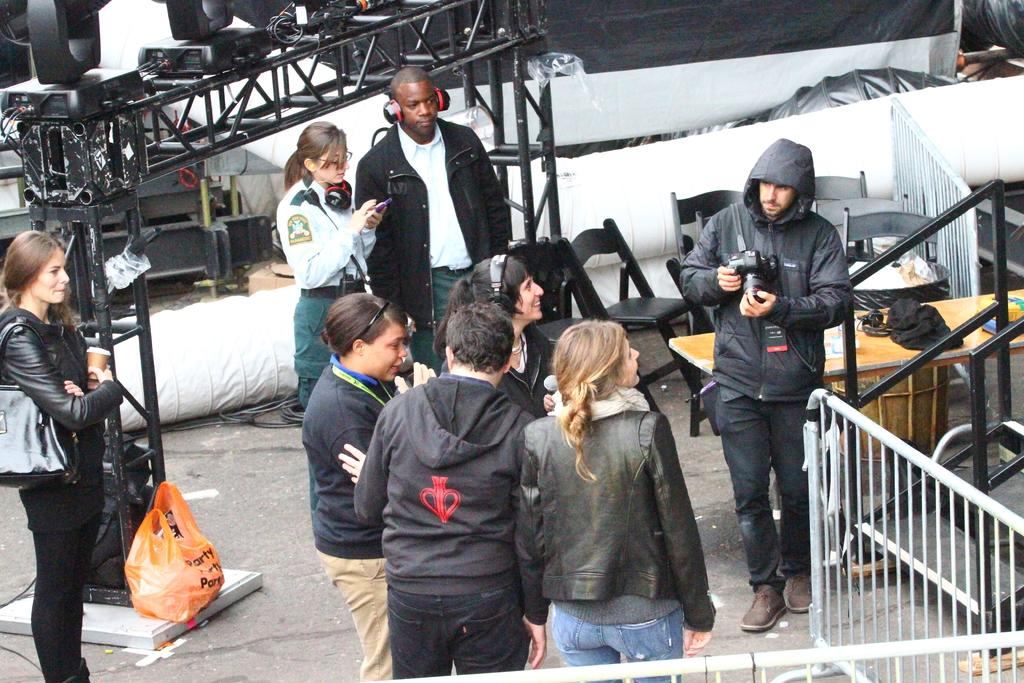What is happening with the people in the image? There are people standing on the land in the image. Can you describe the gender of the people in the image? There are both men and women in the image. What can be seen on the right side of the image? There is a railing on the right side of the image. What furniture is present in the image? There are chairs in front of a table in the image. What type of yarn is being used to create the steam in the image? There is no yarn or steam present in the image. What color is the sheet draped over the chairs in the image? There is no sheet present in the image; only chairs and a table are visible. 